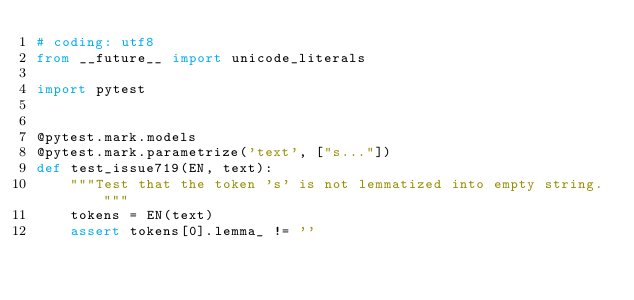<code> <loc_0><loc_0><loc_500><loc_500><_Python_># coding: utf8
from __future__ import unicode_literals

import pytest


@pytest.mark.models
@pytest.mark.parametrize('text', ["s..."])
def test_issue719(EN, text):
    """Test that the token 's' is not lemmatized into empty string."""
    tokens = EN(text)
    assert tokens[0].lemma_ != ''
</code> 